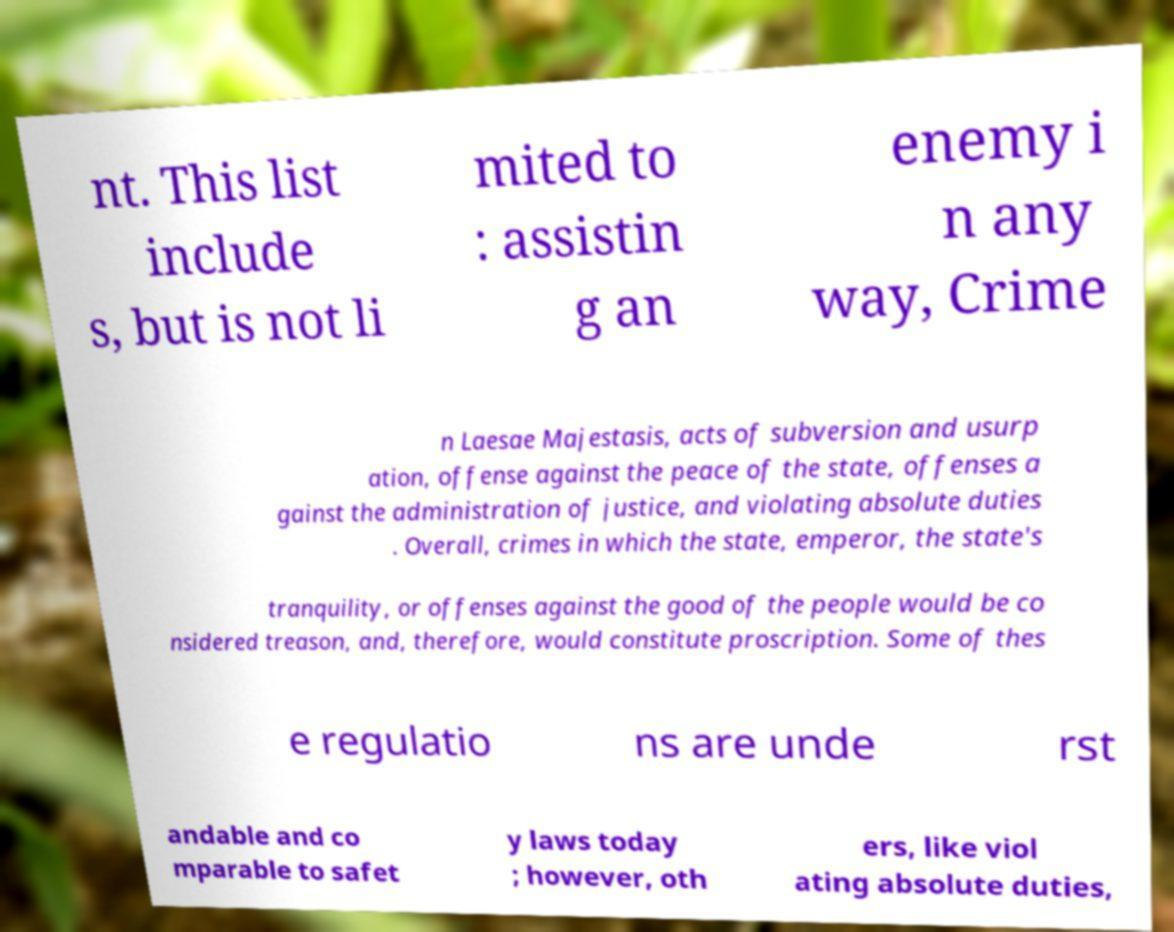Please identify and transcribe the text found in this image. nt. This list include s, but is not li mited to : assistin g an enemy i n any way, Crime n Laesae Majestasis, acts of subversion and usurp ation, offense against the peace of the state, offenses a gainst the administration of justice, and violating absolute duties . Overall, crimes in which the state, emperor, the state's tranquility, or offenses against the good of the people would be co nsidered treason, and, therefore, would constitute proscription. Some of thes e regulatio ns are unde rst andable and co mparable to safet y laws today ; however, oth ers, like viol ating absolute duties, 